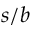<formula> <loc_0><loc_0><loc_500><loc_500>s / b</formula> 